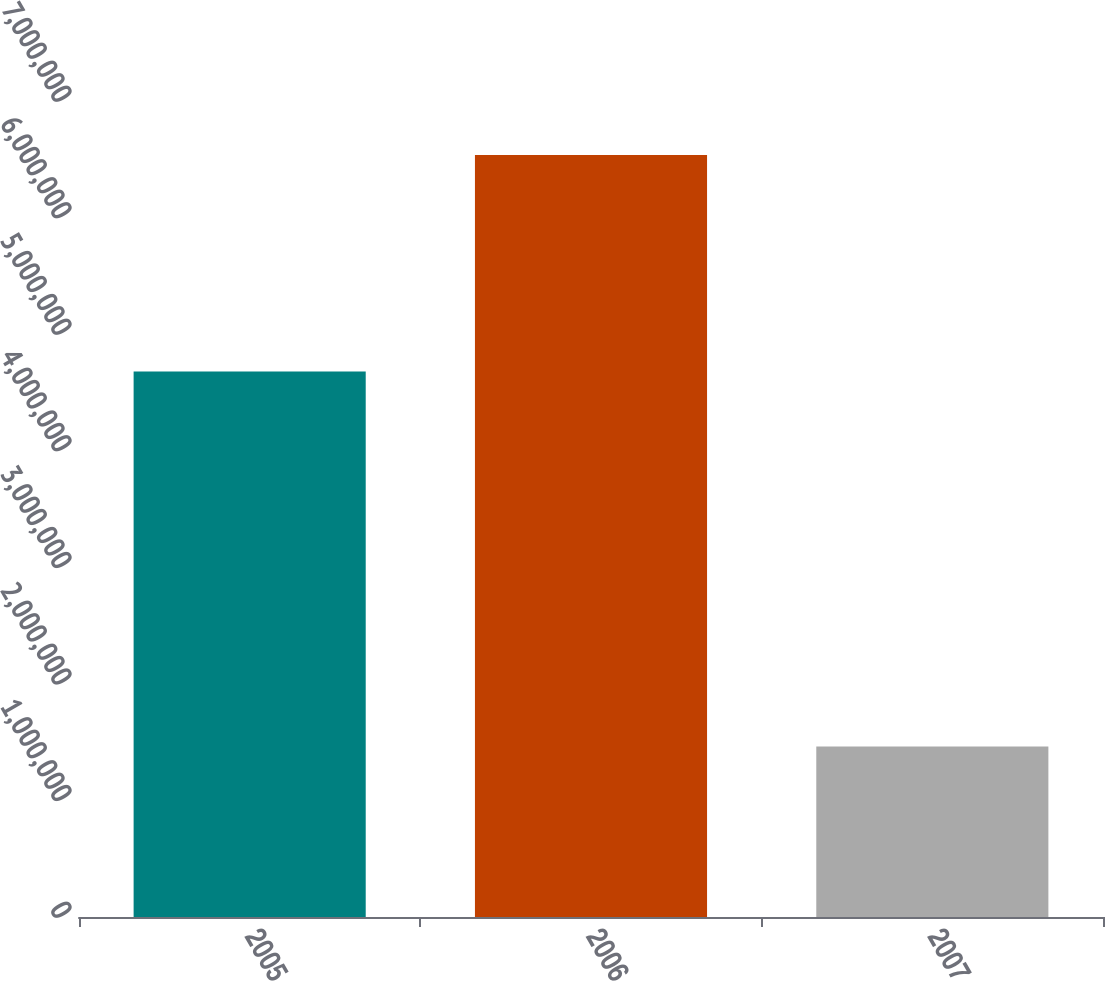Convert chart. <chart><loc_0><loc_0><loc_500><loc_500><bar_chart><fcel>2005<fcel>2006<fcel>2007<nl><fcel>4.67913e+06<fcel>6.53624e+06<fcel>1.46254e+06<nl></chart> 